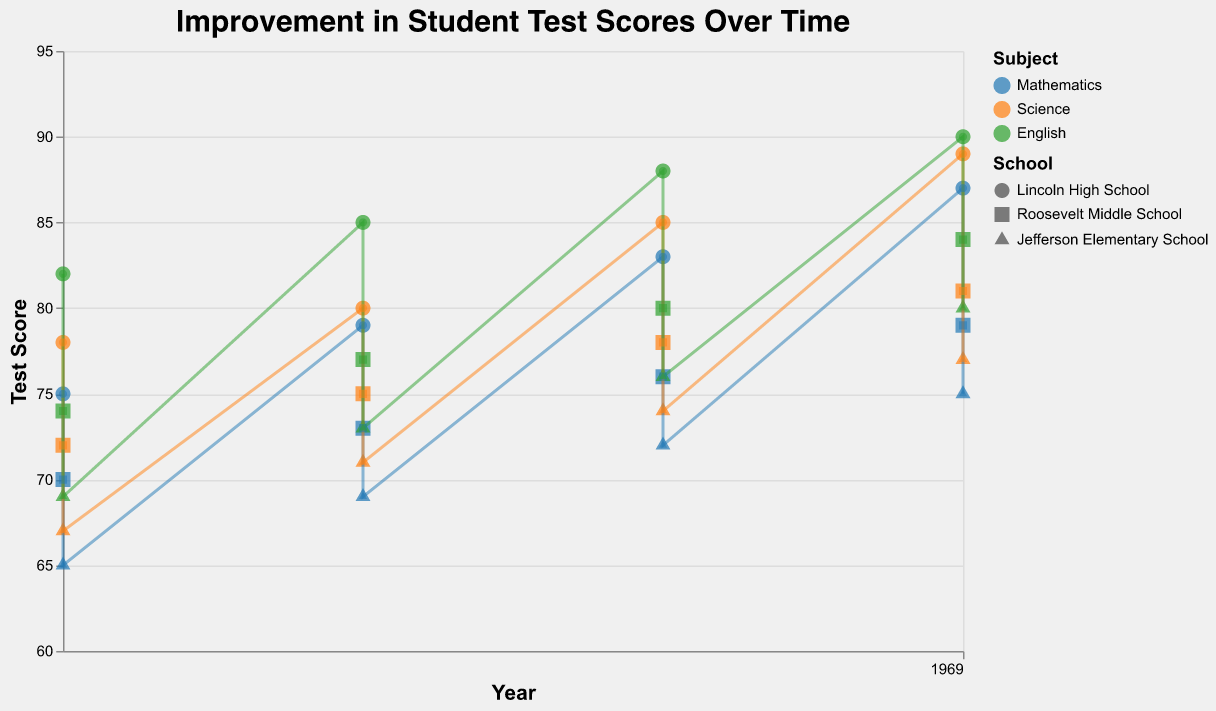What is the overall trend in student test scores over time for all subjects? By observing the positions and trend lines of the data points from 2010 to 2016, we can see that the test scores for all subjects (Mathematics, Science, English) tend to increase over time, indicating an overall positive trend.
Answer: Increasing Which subject showed the most significant improvement in test scores at Lincoln High School from 2010 to 2016? By comparing the trend lines for each subject at Lincoln High School over the timeframe, it is evident that all subjects experienced improvement. However, the subject with the most dramatic improvement, as illustrated by the steepest trend line, is Mathematics, which increased from 75 to 87.
Answer: Mathematics How did Roosevelt Middle School's Mathematics test scores change from 2010 to 2016? By looking at the data points for Roosevelt Middle School's Mathematics test scores from 2010 (70) to 2016 (79), they show a steady increase over time.
Answer: They increased from 70 to 79 Which school had the highest test score in English in 2014? To answer this, we need to check the English test scores for all three schools in 2014. Lincoln High School had the highest English score of 88 compared to the other two schools.
Answer: Lincoln High School Between Science and English, which subject showed a greater increase in test scores at Jefferson Elementary School from 2010 to 2016? By comparing the increase in test scores for Science and English from 2010 to 2016 at Jefferson Elementary School, English increased from 69 to 80 (11 points) while Science increased from 67 to 77 (10 points). Hence, English showed a greater increase.
Answer: English Which year had the highest overall test scores across all subjects and schools? By analyzing the trend lines and observing the clustering of higher scores, 2016 appears to be the year in which all test scores across subjects and schools reached their highest levels.
Answer: 2016 What was the test score trend for Science at Jefferson Elementary School from 2010 to 2016? Observing the Science scores at Jefferson Elementary School, they moved from 67 in 2010, to 71 in 2012, to 74 in 2014, and finally to 77 in 2016, demonstrating a consistent upward trend.
Answer: Upward trend Compare the improvement in test scores for Mathematics at Lincoln High School and Roosevelt Middle School between 2010 and 2016. By comparing the Mathematics scores for Lincoln High School (75 to 87) and Roosevelt Middle School (70 to 79) from 2010 to 2016, Lincoln High School improved by 12 points while Roosevelt Middle School improved by 9 points, indicating Lincoln High School had a greater improvement.
Answer: Lincoln High School In which subject did Jefferson Elementary School score the lowest in 2010, and what was the score? By looking at the test scores for Jefferson Elementary School in 2010, Mathematics had the lowest score of 65.
Answer: Mathematics, 65 